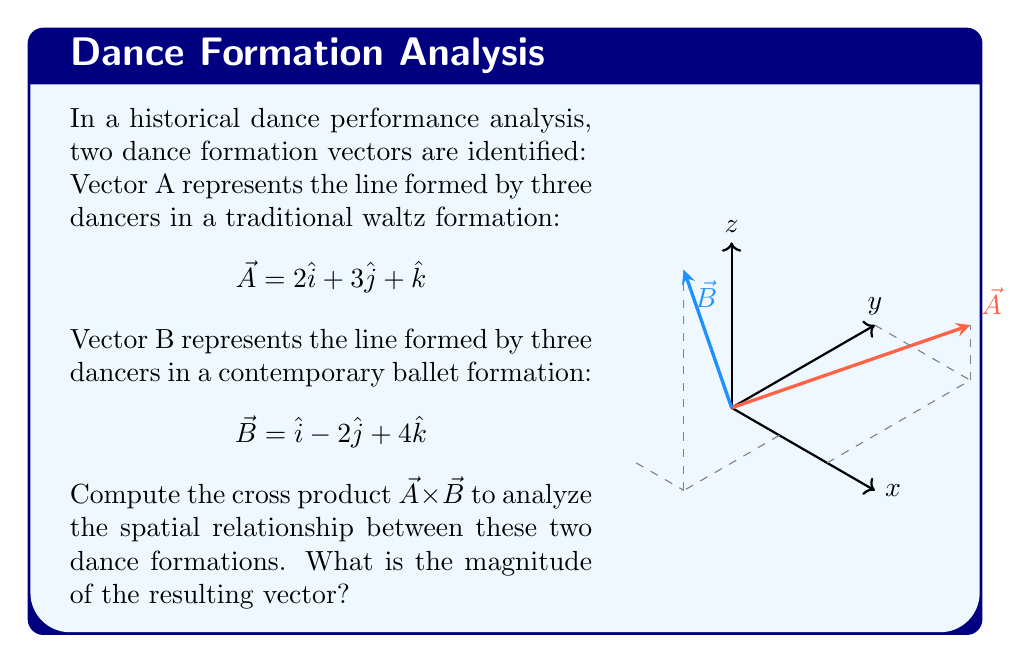Provide a solution to this math problem. To compute the cross product $\vec{A} \times \vec{B}$ and find its magnitude, we'll follow these steps:

1) Recall the formula for cross product:
   $$\vec{A} \times \vec{B} = (a_yb_z - a_zb_y)\hat{i} + (a_zb_x - a_xb_z)\hat{j} + (a_xb_y - a_yb_x)\hat{k}$$

2) Identify the components:
   $\vec{A} = 2\hat{i} + 3\hat{j} + \hat{k}$, so $a_x = 2$, $a_y = 3$, $a_z = 1$
   $\vec{B} = \hat{i} - 2\hat{j} + 4\hat{k}$, so $b_x = 1$, $b_y = -2$, $b_z = 4$

3) Calculate each component of the resulting vector:
   $i$ component: $a_yb_z - a_zb_y = (3)(4) - (1)(-2) = 12 + 2 = 14$
   $j$ component: $a_zb_x - a_xb_z = (1)(1) - (2)(4) = 1 - 8 = -7$
   $k$ component: $a_xb_y - a_yb_x = (2)(-2) - (3)(1) = -4 - 3 = -7$

4) The resulting vector is:
   $$\vec{A} \times \vec{B} = 14\hat{i} - 7\hat{j} - 7\hat{k}$$

5) To find the magnitude, use the Pythagorean theorem:
   $$|\vec{A} \times \vec{B}| = \sqrt{14^2 + (-7)^2 + (-7)^2}$$
   $$= \sqrt{196 + 49 + 49} = \sqrt{294} = 7\sqrt{6}$$

The magnitude represents the area of the parallelogram formed by these two dance formation vectors, which can be interpreted as a measure of how different or orthogonal the two formations are in 3D space.
Answer: $7\sqrt{6}$ 